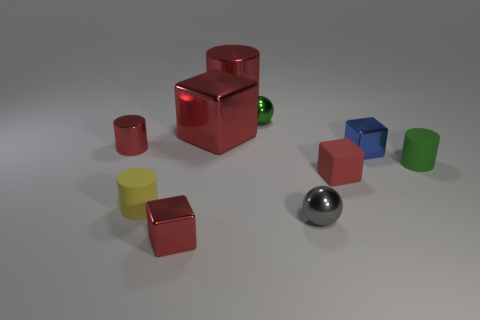What is the shape of the big metal thing that is the same color as the big metal cylinder?
Offer a terse response. Cube. Is the number of green matte cylinders that are to the left of the matte cube the same as the number of red metal cubes that are in front of the small gray metallic object?
Provide a short and direct response. No. What color is the other tiny metal thing that is the same shape as the tiny green shiny thing?
Provide a succinct answer. Gray. Is there any other thing that has the same shape as the yellow matte object?
Offer a very short reply. Yes. There is a matte cylinder that is to the right of the big red metallic cylinder; is it the same color as the large shiny cylinder?
Give a very brief answer. No. There is a green rubber object that is the same shape as the yellow matte object; what is its size?
Your response must be concise. Small. How many tiny green spheres have the same material as the gray ball?
Offer a very short reply. 1. There is a small metal block in front of the small red matte object on the right side of the yellow cylinder; is there a small yellow cylinder right of it?
Provide a succinct answer. No. There is a tiny gray thing; what shape is it?
Give a very brief answer. Sphere. Does the red block to the right of the gray metal ball have the same material as the yellow cylinder in front of the green ball?
Give a very brief answer. Yes. 